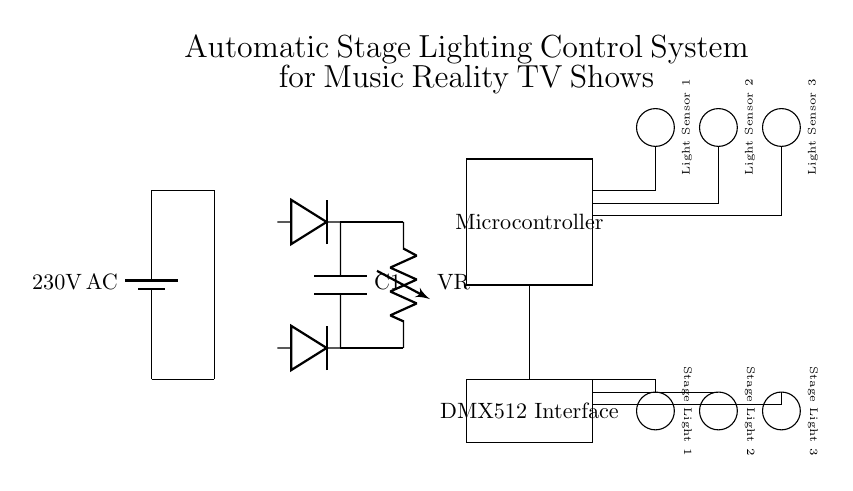What is the main power supply voltage in this circuit? The main power supply voltage is indicated as 230V AC. This is drawn from the battery symbol at the start of the circuit diagram, which provides the initial power input for the entire system.
Answer: 230V AC What components are used for light control outputs? The light control outputs are represented by three circles, each labeled as Stage Light 1, Stage Light 2, and Stage Light 3. These symbols directly signify the load components connected to the output of the circuit, facilitating the control of stage lighting.
Answer: Stage Light 1, Stage Light 2, Stage Light 3 How many light sensors are in the system? There are three light sensors, each depicted as a circle in the circuit diagram labeled Light Sensor 1, Light Sensor 2, and Light Sensor 3. The presence of these sensors allows the system to adjust lighting based on ambient light conditions.
Answer: Three What is the function of the voltage regulator in this circuit? The voltage regulator, labeled as VR, ensures that the voltage output from the power circuit remains stable and at a desired level for the connected components. It plays a critical role in maintaining consistent performance of the overall system by preventing voltage fluctuations.
Answer: Voltage stabilization How does the microcontroller interact with the sensors? The microcontroller connects to the three light sensors through individual lines, allowing it to receive input from each sensor. This data enables the microcontroller to make real-time decisions about lighting control, adjusting intensity based on the light levels detected.
Answer: Receives input from sensors What is the purpose of the DMX512 interface in the circuit? The DMX512 interface allows for digital communication with the stage lights, enabling complex control over lighting parameters like intensity and color. It handles commands sent from the microcontroller to the stage lights, facilitating synchronized effects during performances.
Answer: Digital communication for light control 